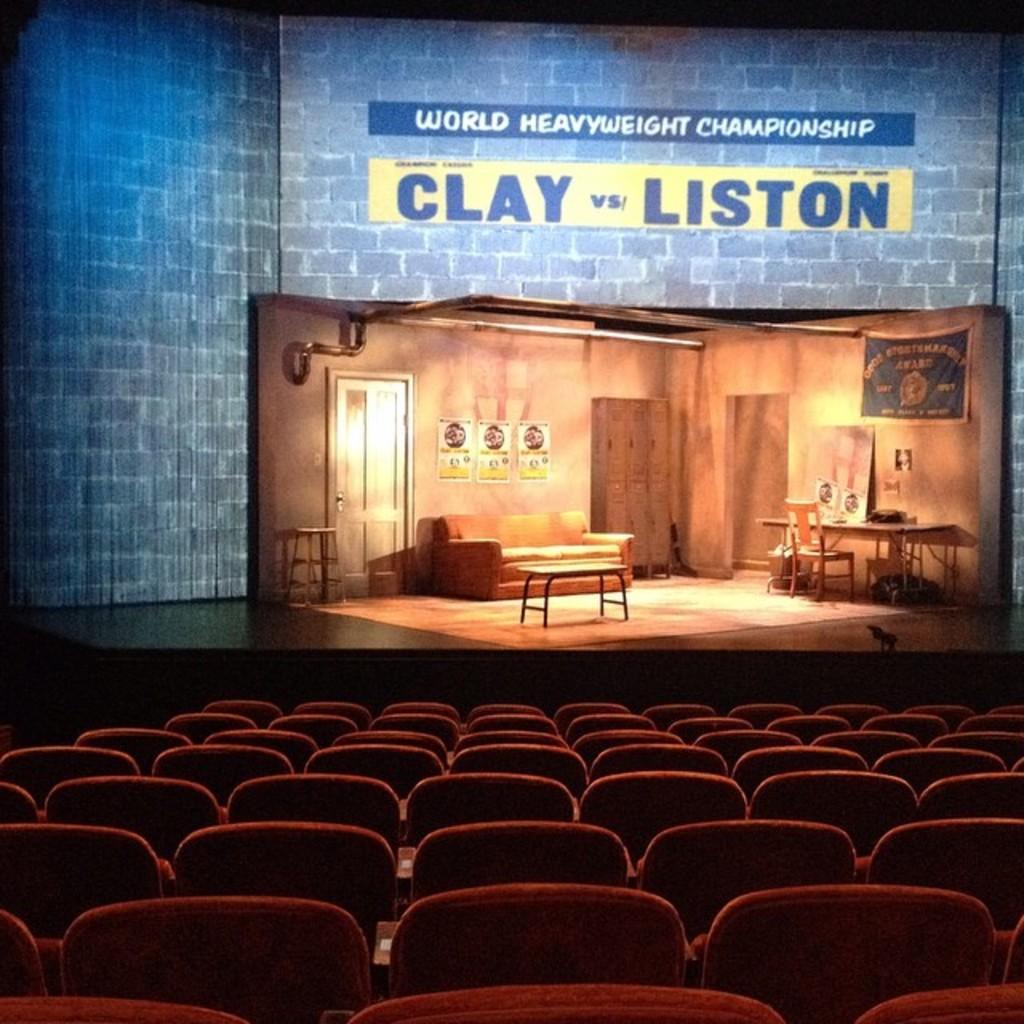In one or two sentences, can you explain what this image depicts? In this image i can see few chairs at the back ground there is a stage, couch,door and the papers attached to the wall. 